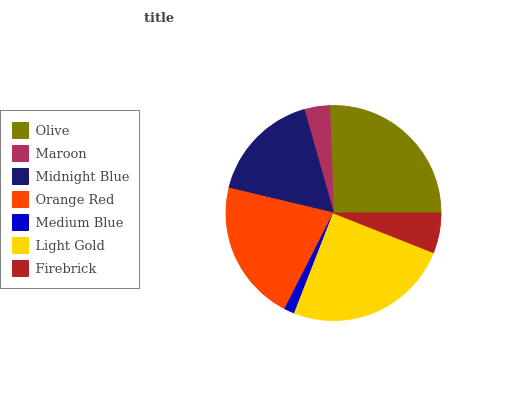Is Medium Blue the minimum?
Answer yes or no. Yes. Is Olive the maximum?
Answer yes or no. Yes. Is Maroon the minimum?
Answer yes or no. No. Is Maroon the maximum?
Answer yes or no. No. Is Olive greater than Maroon?
Answer yes or no. Yes. Is Maroon less than Olive?
Answer yes or no. Yes. Is Maroon greater than Olive?
Answer yes or no. No. Is Olive less than Maroon?
Answer yes or no. No. Is Midnight Blue the high median?
Answer yes or no. Yes. Is Midnight Blue the low median?
Answer yes or no. Yes. Is Maroon the high median?
Answer yes or no. No. Is Orange Red the low median?
Answer yes or no. No. 